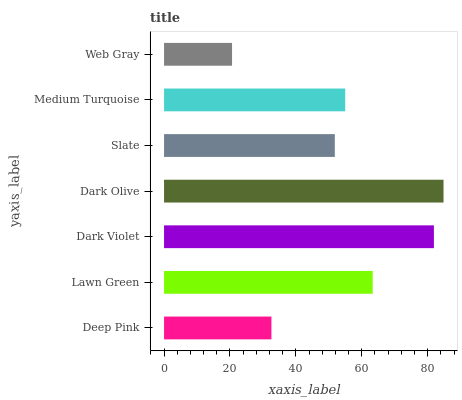Is Web Gray the minimum?
Answer yes or no. Yes. Is Dark Olive the maximum?
Answer yes or no. Yes. Is Lawn Green the minimum?
Answer yes or no. No. Is Lawn Green the maximum?
Answer yes or no. No. Is Lawn Green greater than Deep Pink?
Answer yes or no. Yes. Is Deep Pink less than Lawn Green?
Answer yes or no. Yes. Is Deep Pink greater than Lawn Green?
Answer yes or no. No. Is Lawn Green less than Deep Pink?
Answer yes or no. No. Is Medium Turquoise the high median?
Answer yes or no. Yes. Is Medium Turquoise the low median?
Answer yes or no. Yes. Is Deep Pink the high median?
Answer yes or no. No. Is Web Gray the low median?
Answer yes or no. No. 